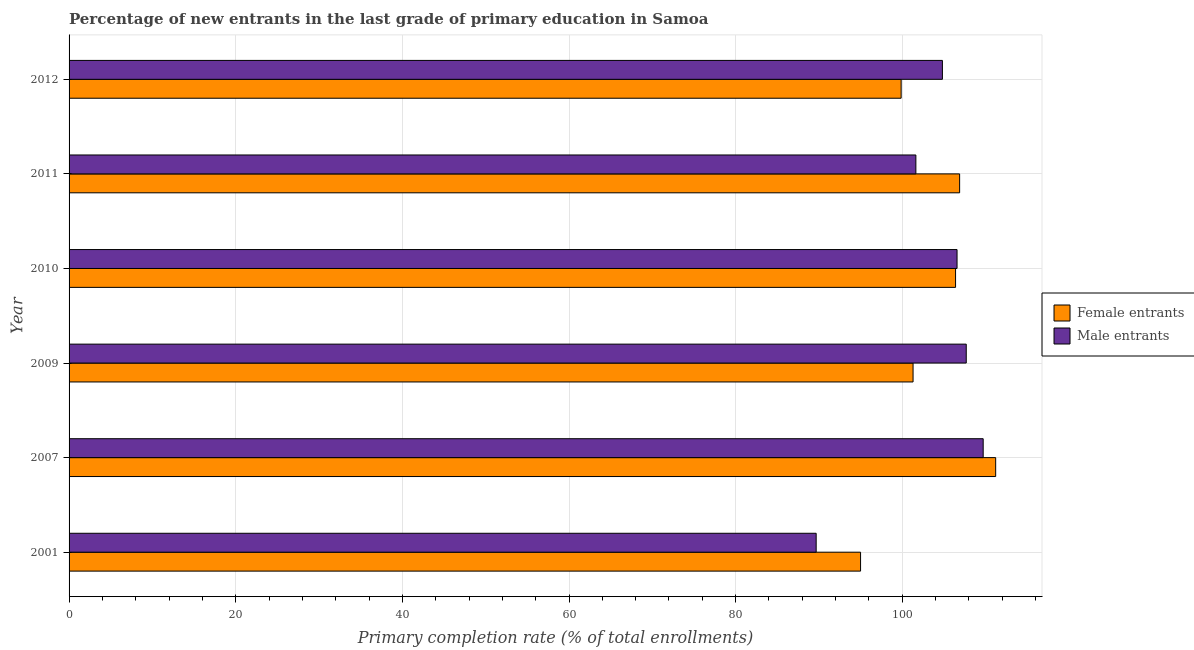How many groups of bars are there?
Your answer should be very brief. 6. Are the number of bars per tick equal to the number of legend labels?
Provide a succinct answer. Yes. Are the number of bars on each tick of the Y-axis equal?
Provide a short and direct response. Yes. How many bars are there on the 5th tick from the bottom?
Ensure brevity in your answer.  2. What is the label of the 4th group of bars from the top?
Your response must be concise. 2009. What is the primary completion rate of male entrants in 2012?
Ensure brevity in your answer.  104.82. Across all years, what is the maximum primary completion rate of female entrants?
Give a very brief answer. 111.21. Across all years, what is the minimum primary completion rate of male entrants?
Offer a very short reply. 89.66. In which year was the primary completion rate of male entrants maximum?
Keep it short and to the point. 2007. What is the total primary completion rate of female entrants in the graph?
Your answer should be compact. 620.63. What is the difference between the primary completion rate of female entrants in 2007 and that in 2009?
Your answer should be compact. 9.92. What is the difference between the primary completion rate of female entrants in 2010 and the primary completion rate of male entrants in 2012?
Offer a very short reply. 1.58. What is the average primary completion rate of male entrants per year?
Provide a short and direct response. 103.34. In the year 2007, what is the difference between the primary completion rate of male entrants and primary completion rate of female entrants?
Provide a succinct answer. -1.5. In how many years, is the primary completion rate of male entrants greater than 72 %?
Provide a short and direct response. 6. What is the ratio of the primary completion rate of male entrants in 2001 to that in 2007?
Your response must be concise. 0.82. Is the primary completion rate of female entrants in 2009 less than that in 2012?
Provide a short and direct response. No. What is the difference between the highest and the second highest primary completion rate of male entrants?
Your response must be concise. 2.03. What is the difference between the highest and the lowest primary completion rate of male entrants?
Provide a succinct answer. 20.05. Is the sum of the primary completion rate of female entrants in 2001 and 2010 greater than the maximum primary completion rate of male entrants across all years?
Give a very brief answer. Yes. What does the 1st bar from the top in 2010 represents?
Provide a succinct answer. Male entrants. What does the 2nd bar from the bottom in 2011 represents?
Offer a terse response. Male entrants. How many bars are there?
Offer a very short reply. 12. How many years are there in the graph?
Keep it short and to the point. 6. Are the values on the major ticks of X-axis written in scientific E-notation?
Your response must be concise. No. Does the graph contain grids?
Give a very brief answer. Yes. Where does the legend appear in the graph?
Provide a short and direct response. Center right. How many legend labels are there?
Your answer should be compact. 2. How are the legend labels stacked?
Your answer should be compact. Vertical. What is the title of the graph?
Offer a terse response. Percentage of new entrants in the last grade of primary education in Samoa. Does "Registered firms" appear as one of the legend labels in the graph?
Give a very brief answer. No. What is the label or title of the X-axis?
Offer a terse response. Primary completion rate (% of total enrollments). What is the Primary completion rate (% of total enrollments) of Female entrants in 2001?
Your answer should be very brief. 94.99. What is the Primary completion rate (% of total enrollments) of Male entrants in 2001?
Provide a succinct answer. 89.66. What is the Primary completion rate (% of total enrollments) in Female entrants in 2007?
Provide a succinct answer. 111.21. What is the Primary completion rate (% of total enrollments) of Male entrants in 2007?
Your answer should be compact. 109.71. What is the Primary completion rate (% of total enrollments) in Female entrants in 2009?
Ensure brevity in your answer.  101.29. What is the Primary completion rate (% of total enrollments) in Male entrants in 2009?
Make the answer very short. 107.68. What is the Primary completion rate (% of total enrollments) in Female entrants in 2010?
Offer a very short reply. 106.39. What is the Primary completion rate (% of total enrollments) of Male entrants in 2010?
Ensure brevity in your answer.  106.57. What is the Primary completion rate (% of total enrollments) in Female entrants in 2011?
Your response must be concise. 106.88. What is the Primary completion rate (% of total enrollments) of Male entrants in 2011?
Your response must be concise. 101.63. What is the Primary completion rate (% of total enrollments) of Female entrants in 2012?
Your answer should be compact. 99.86. What is the Primary completion rate (% of total enrollments) of Male entrants in 2012?
Your answer should be very brief. 104.82. Across all years, what is the maximum Primary completion rate (% of total enrollments) of Female entrants?
Keep it short and to the point. 111.21. Across all years, what is the maximum Primary completion rate (% of total enrollments) of Male entrants?
Offer a terse response. 109.71. Across all years, what is the minimum Primary completion rate (% of total enrollments) of Female entrants?
Your answer should be very brief. 94.99. Across all years, what is the minimum Primary completion rate (% of total enrollments) in Male entrants?
Make the answer very short. 89.66. What is the total Primary completion rate (% of total enrollments) in Female entrants in the graph?
Your response must be concise. 620.63. What is the total Primary completion rate (% of total enrollments) in Male entrants in the graph?
Ensure brevity in your answer.  620.07. What is the difference between the Primary completion rate (% of total enrollments) of Female entrants in 2001 and that in 2007?
Make the answer very short. -16.22. What is the difference between the Primary completion rate (% of total enrollments) in Male entrants in 2001 and that in 2007?
Offer a terse response. -20.05. What is the difference between the Primary completion rate (% of total enrollments) of Female entrants in 2001 and that in 2009?
Your response must be concise. -6.3. What is the difference between the Primary completion rate (% of total enrollments) in Male entrants in 2001 and that in 2009?
Your answer should be very brief. -18.01. What is the difference between the Primary completion rate (% of total enrollments) in Female entrants in 2001 and that in 2010?
Provide a succinct answer. -11.4. What is the difference between the Primary completion rate (% of total enrollments) of Male entrants in 2001 and that in 2010?
Your answer should be very brief. -16.91. What is the difference between the Primary completion rate (% of total enrollments) in Female entrants in 2001 and that in 2011?
Provide a succinct answer. -11.89. What is the difference between the Primary completion rate (% of total enrollments) of Male entrants in 2001 and that in 2011?
Offer a very short reply. -11.97. What is the difference between the Primary completion rate (% of total enrollments) in Female entrants in 2001 and that in 2012?
Offer a terse response. -4.87. What is the difference between the Primary completion rate (% of total enrollments) in Male entrants in 2001 and that in 2012?
Make the answer very short. -15.15. What is the difference between the Primary completion rate (% of total enrollments) of Female entrants in 2007 and that in 2009?
Keep it short and to the point. 9.92. What is the difference between the Primary completion rate (% of total enrollments) of Male entrants in 2007 and that in 2009?
Give a very brief answer. 2.03. What is the difference between the Primary completion rate (% of total enrollments) in Female entrants in 2007 and that in 2010?
Ensure brevity in your answer.  4.81. What is the difference between the Primary completion rate (% of total enrollments) in Male entrants in 2007 and that in 2010?
Offer a terse response. 3.14. What is the difference between the Primary completion rate (% of total enrollments) of Female entrants in 2007 and that in 2011?
Make the answer very short. 4.33. What is the difference between the Primary completion rate (% of total enrollments) of Male entrants in 2007 and that in 2011?
Give a very brief answer. 8.08. What is the difference between the Primary completion rate (% of total enrollments) in Female entrants in 2007 and that in 2012?
Your answer should be compact. 11.35. What is the difference between the Primary completion rate (% of total enrollments) in Male entrants in 2007 and that in 2012?
Your answer should be very brief. 4.89. What is the difference between the Primary completion rate (% of total enrollments) of Female entrants in 2009 and that in 2010?
Offer a very short reply. -5.1. What is the difference between the Primary completion rate (% of total enrollments) of Male entrants in 2009 and that in 2010?
Offer a terse response. 1.1. What is the difference between the Primary completion rate (% of total enrollments) of Female entrants in 2009 and that in 2011?
Offer a terse response. -5.59. What is the difference between the Primary completion rate (% of total enrollments) of Male entrants in 2009 and that in 2011?
Provide a short and direct response. 6.05. What is the difference between the Primary completion rate (% of total enrollments) in Female entrants in 2009 and that in 2012?
Offer a very short reply. 1.43. What is the difference between the Primary completion rate (% of total enrollments) of Male entrants in 2009 and that in 2012?
Ensure brevity in your answer.  2.86. What is the difference between the Primary completion rate (% of total enrollments) in Female entrants in 2010 and that in 2011?
Your response must be concise. -0.49. What is the difference between the Primary completion rate (% of total enrollments) in Male entrants in 2010 and that in 2011?
Your answer should be compact. 4.94. What is the difference between the Primary completion rate (% of total enrollments) of Female entrants in 2010 and that in 2012?
Offer a very short reply. 6.53. What is the difference between the Primary completion rate (% of total enrollments) of Male entrants in 2010 and that in 2012?
Your answer should be very brief. 1.76. What is the difference between the Primary completion rate (% of total enrollments) of Female entrants in 2011 and that in 2012?
Offer a very short reply. 7.02. What is the difference between the Primary completion rate (% of total enrollments) in Male entrants in 2011 and that in 2012?
Make the answer very short. -3.18. What is the difference between the Primary completion rate (% of total enrollments) in Female entrants in 2001 and the Primary completion rate (% of total enrollments) in Male entrants in 2007?
Keep it short and to the point. -14.72. What is the difference between the Primary completion rate (% of total enrollments) of Female entrants in 2001 and the Primary completion rate (% of total enrollments) of Male entrants in 2009?
Offer a very short reply. -12.68. What is the difference between the Primary completion rate (% of total enrollments) of Female entrants in 2001 and the Primary completion rate (% of total enrollments) of Male entrants in 2010?
Your answer should be compact. -11.58. What is the difference between the Primary completion rate (% of total enrollments) of Female entrants in 2001 and the Primary completion rate (% of total enrollments) of Male entrants in 2011?
Provide a succinct answer. -6.64. What is the difference between the Primary completion rate (% of total enrollments) in Female entrants in 2001 and the Primary completion rate (% of total enrollments) in Male entrants in 2012?
Your answer should be very brief. -9.82. What is the difference between the Primary completion rate (% of total enrollments) of Female entrants in 2007 and the Primary completion rate (% of total enrollments) of Male entrants in 2009?
Your response must be concise. 3.53. What is the difference between the Primary completion rate (% of total enrollments) in Female entrants in 2007 and the Primary completion rate (% of total enrollments) in Male entrants in 2010?
Make the answer very short. 4.64. What is the difference between the Primary completion rate (% of total enrollments) of Female entrants in 2007 and the Primary completion rate (% of total enrollments) of Male entrants in 2011?
Your answer should be compact. 9.58. What is the difference between the Primary completion rate (% of total enrollments) of Female entrants in 2007 and the Primary completion rate (% of total enrollments) of Male entrants in 2012?
Your answer should be compact. 6.39. What is the difference between the Primary completion rate (% of total enrollments) in Female entrants in 2009 and the Primary completion rate (% of total enrollments) in Male entrants in 2010?
Provide a succinct answer. -5.28. What is the difference between the Primary completion rate (% of total enrollments) in Female entrants in 2009 and the Primary completion rate (% of total enrollments) in Male entrants in 2011?
Keep it short and to the point. -0.34. What is the difference between the Primary completion rate (% of total enrollments) of Female entrants in 2009 and the Primary completion rate (% of total enrollments) of Male entrants in 2012?
Keep it short and to the point. -3.52. What is the difference between the Primary completion rate (% of total enrollments) in Female entrants in 2010 and the Primary completion rate (% of total enrollments) in Male entrants in 2011?
Your response must be concise. 4.76. What is the difference between the Primary completion rate (% of total enrollments) of Female entrants in 2010 and the Primary completion rate (% of total enrollments) of Male entrants in 2012?
Your response must be concise. 1.58. What is the difference between the Primary completion rate (% of total enrollments) of Female entrants in 2011 and the Primary completion rate (% of total enrollments) of Male entrants in 2012?
Your answer should be compact. 2.07. What is the average Primary completion rate (% of total enrollments) in Female entrants per year?
Ensure brevity in your answer.  103.44. What is the average Primary completion rate (% of total enrollments) in Male entrants per year?
Provide a short and direct response. 103.34. In the year 2001, what is the difference between the Primary completion rate (% of total enrollments) in Female entrants and Primary completion rate (% of total enrollments) in Male entrants?
Provide a short and direct response. 5.33. In the year 2007, what is the difference between the Primary completion rate (% of total enrollments) in Female entrants and Primary completion rate (% of total enrollments) in Male entrants?
Offer a terse response. 1.5. In the year 2009, what is the difference between the Primary completion rate (% of total enrollments) of Female entrants and Primary completion rate (% of total enrollments) of Male entrants?
Ensure brevity in your answer.  -6.38. In the year 2010, what is the difference between the Primary completion rate (% of total enrollments) of Female entrants and Primary completion rate (% of total enrollments) of Male entrants?
Offer a terse response. -0.18. In the year 2011, what is the difference between the Primary completion rate (% of total enrollments) in Female entrants and Primary completion rate (% of total enrollments) in Male entrants?
Your response must be concise. 5.25. In the year 2012, what is the difference between the Primary completion rate (% of total enrollments) in Female entrants and Primary completion rate (% of total enrollments) in Male entrants?
Keep it short and to the point. -4.95. What is the ratio of the Primary completion rate (% of total enrollments) of Female entrants in 2001 to that in 2007?
Provide a short and direct response. 0.85. What is the ratio of the Primary completion rate (% of total enrollments) in Male entrants in 2001 to that in 2007?
Ensure brevity in your answer.  0.82. What is the ratio of the Primary completion rate (% of total enrollments) in Female entrants in 2001 to that in 2009?
Provide a short and direct response. 0.94. What is the ratio of the Primary completion rate (% of total enrollments) in Male entrants in 2001 to that in 2009?
Offer a very short reply. 0.83. What is the ratio of the Primary completion rate (% of total enrollments) of Female entrants in 2001 to that in 2010?
Keep it short and to the point. 0.89. What is the ratio of the Primary completion rate (% of total enrollments) in Male entrants in 2001 to that in 2010?
Give a very brief answer. 0.84. What is the ratio of the Primary completion rate (% of total enrollments) in Female entrants in 2001 to that in 2011?
Your answer should be very brief. 0.89. What is the ratio of the Primary completion rate (% of total enrollments) of Male entrants in 2001 to that in 2011?
Your answer should be compact. 0.88. What is the ratio of the Primary completion rate (% of total enrollments) in Female entrants in 2001 to that in 2012?
Provide a short and direct response. 0.95. What is the ratio of the Primary completion rate (% of total enrollments) of Male entrants in 2001 to that in 2012?
Provide a short and direct response. 0.86. What is the ratio of the Primary completion rate (% of total enrollments) of Female entrants in 2007 to that in 2009?
Offer a terse response. 1.1. What is the ratio of the Primary completion rate (% of total enrollments) in Male entrants in 2007 to that in 2009?
Keep it short and to the point. 1.02. What is the ratio of the Primary completion rate (% of total enrollments) in Female entrants in 2007 to that in 2010?
Your answer should be compact. 1.05. What is the ratio of the Primary completion rate (% of total enrollments) of Male entrants in 2007 to that in 2010?
Give a very brief answer. 1.03. What is the ratio of the Primary completion rate (% of total enrollments) in Female entrants in 2007 to that in 2011?
Give a very brief answer. 1.04. What is the ratio of the Primary completion rate (% of total enrollments) of Male entrants in 2007 to that in 2011?
Ensure brevity in your answer.  1.08. What is the ratio of the Primary completion rate (% of total enrollments) of Female entrants in 2007 to that in 2012?
Make the answer very short. 1.11. What is the ratio of the Primary completion rate (% of total enrollments) in Male entrants in 2007 to that in 2012?
Your response must be concise. 1.05. What is the ratio of the Primary completion rate (% of total enrollments) in Female entrants in 2009 to that in 2010?
Your answer should be very brief. 0.95. What is the ratio of the Primary completion rate (% of total enrollments) in Male entrants in 2009 to that in 2010?
Provide a short and direct response. 1.01. What is the ratio of the Primary completion rate (% of total enrollments) of Female entrants in 2009 to that in 2011?
Provide a succinct answer. 0.95. What is the ratio of the Primary completion rate (% of total enrollments) of Male entrants in 2009 to that in 2011?
Offer a terse response. 1.06. What is the ratio of the Primary completion rate (% of total enrollments) of Female entrants in 2009 to that in 2012?
Your response must be concise. 1.01. What is the ratio of the Primary completion rate (% of total enrollments) of Male entrants in 2009 to that in 2012?
Provide a short and direct response. 1.03. What is the ratio of the Primary completion rate (% of total enrollments) of Male entrants in 2010 to that in 2011?
Your response must be concise. 1.05. What is the ratio of the Primary completion rate (% of total enrollments) in Female entrants in 2010 to that in 2012?
Offer a terse response. 1.07. What is the ratio of the Primary completion rate (% of total enrollments) in Male entrants in 2010 to that in 2012?
Provide a succinct answer. 1.02. What is the ratio of the Primary completion rate (% of total enrollments) in Female entrants in 2011 to that in 2012?
Provide a short and direct response. 1.07. What is the ratio of the Primary completion rate (% of total enrollments) of Male entrants in 2011 to that in 2012?
Give a very brief answer. 0.97. What is the difference between the highest and the second highest Primary completion rate (% of total enrollments) of Female entrants?
Your answer should be very brief. 4.33. What is the difference between the highest and the second highest Primary completion rate (% of total enrollments) of Male entrants?
Keep it short and to the point. 2.03. What is the difference between the highest and the lowest Primary completion rate (% of total enrollments) in Female entrants?
Give a very brief answer. 16.22. What is the difference between the highest and the lowest Primary completion rate (% of total enrollments) of Male entrants?
Make the answer very short. 20.05. 